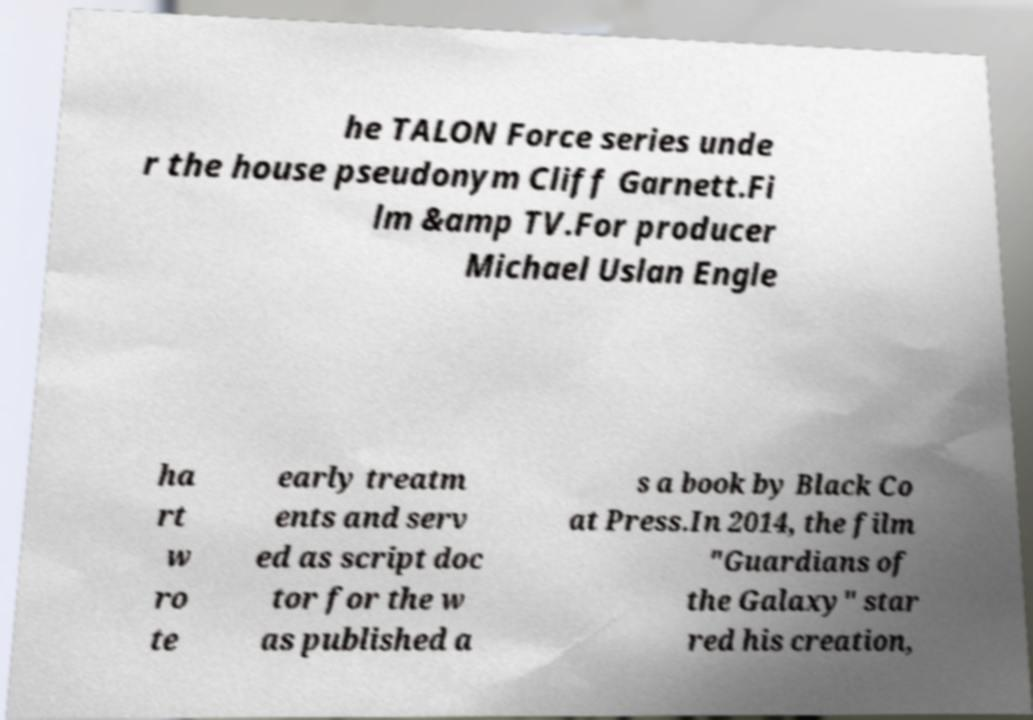I need the written content from this picture converted into text. Can you do that? he TALON Force series unde r the house pseudonym Cliff Garnett.Fi lm &amp TV.For producer Michael Uslan Engle ha rt w ro te early treatm ents and serv ed as script doc tor for the w as published a s a book by Black Co at Press.In 2014, the film "Guardians of the Galaxy" star red his creation, 